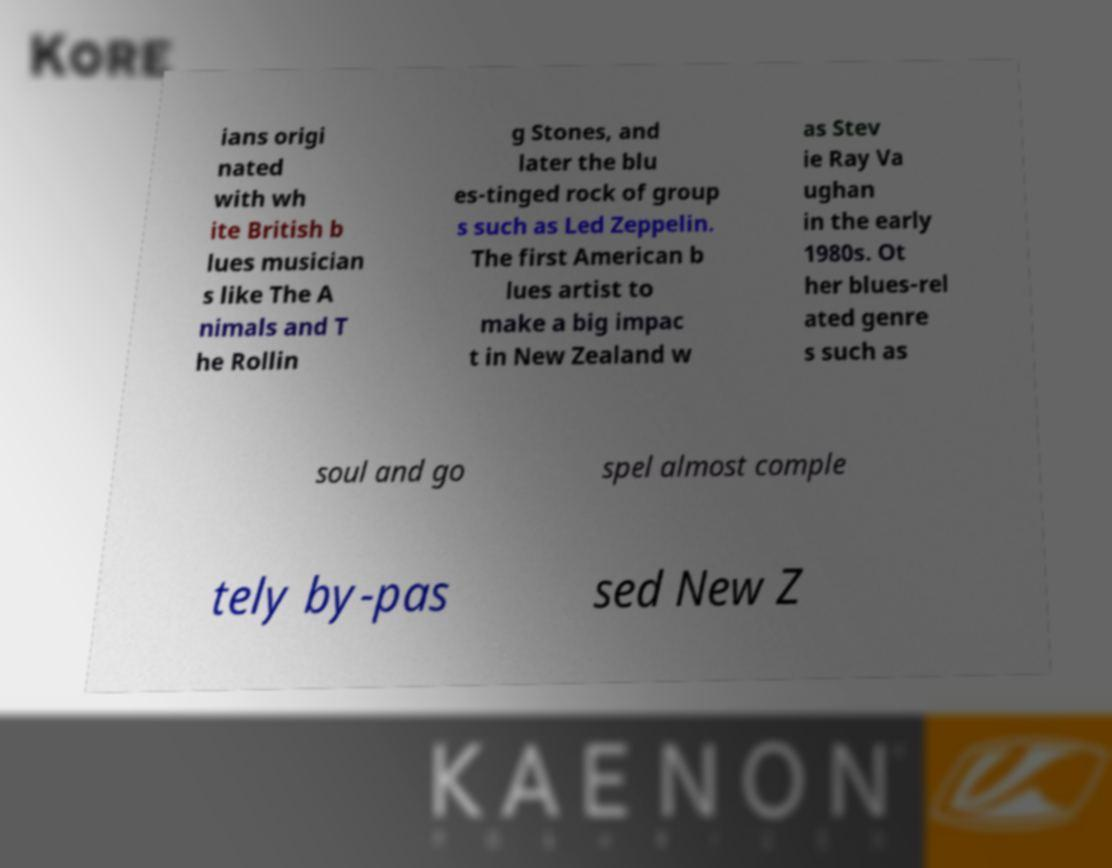Please read and relay the text visible in this image. What does it say? ians origi nated with wh ite British b lues musician s like The A nimals and T he Rollin g Stones, and later the blu es-tinged rock of group s such as Led Zeppelin. The first American b lues artist to make a big impac t in New Zealand w as Stev ie Ray Va ughan in the early 1980s. Ot her blues-rel ated genre s such as soul and go spel almost comple tely by-pas sed New Z 